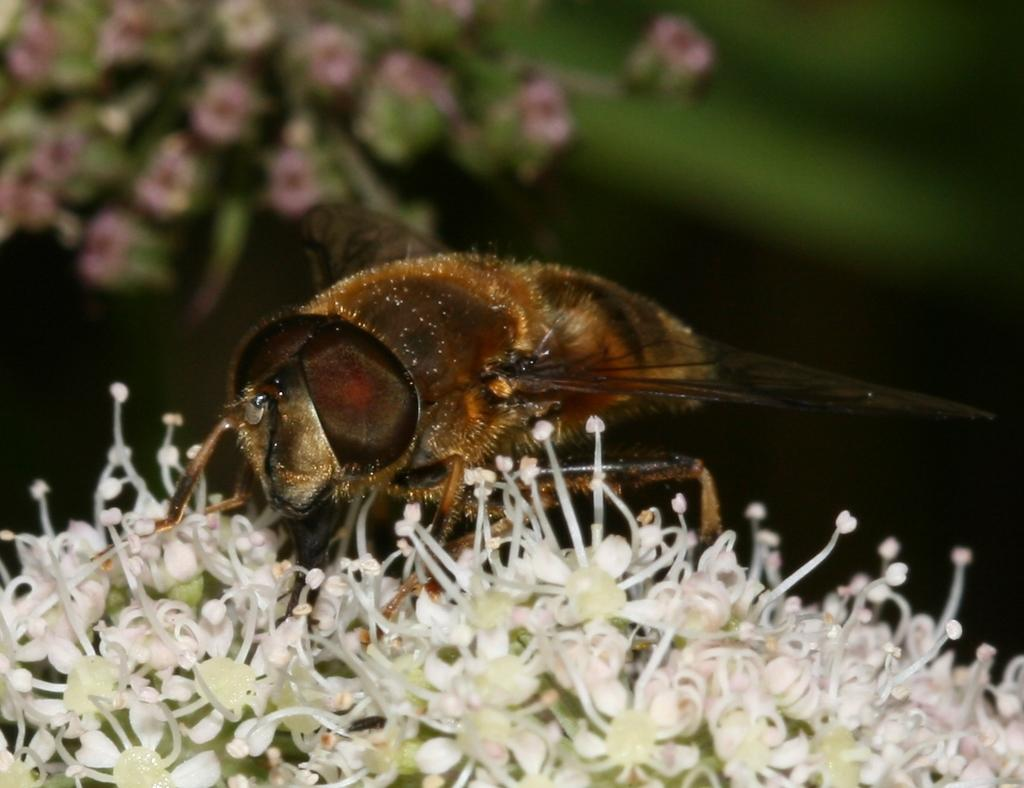What is located at the bottom of the image? There are flowers at the bottom of the image. What is on the flowers in the image? There is a bee on the flowers. What can be seen in the background of the image? In the background, flowers and leaves are visible. What type of bait is the bee using to attract attention in the image? There is no bait present in the image, and the bee is not trying to attract attention. What type of silk is visible on the flowers in the image? There is no silk visible on the flowers in the image. 